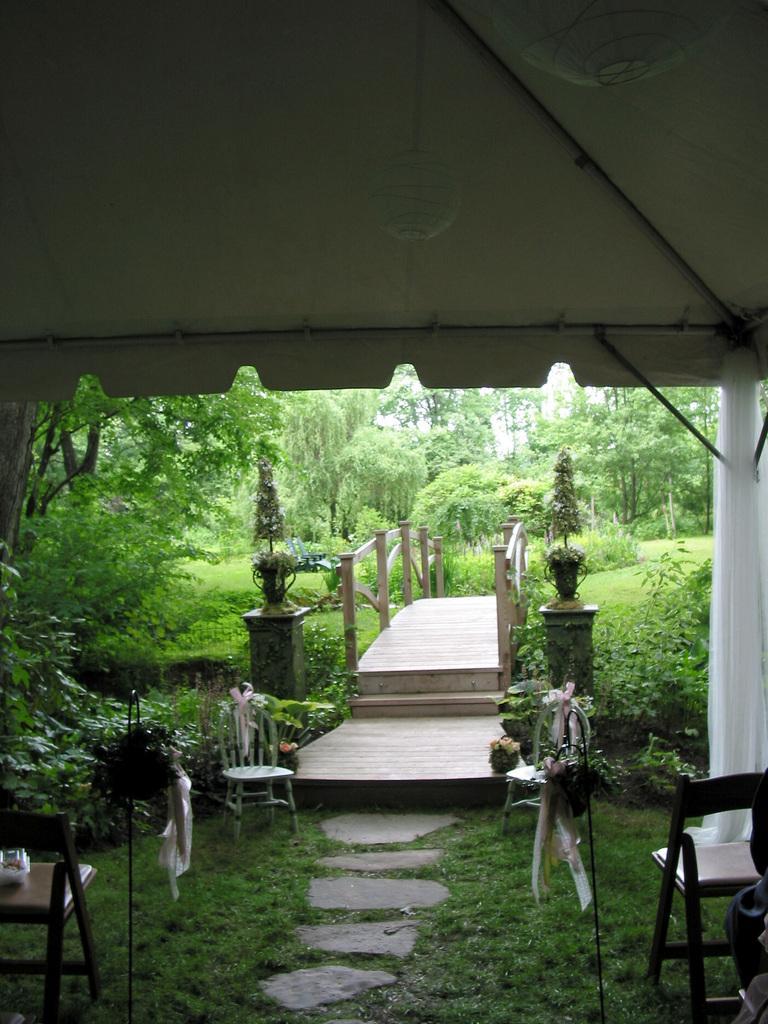How would you summarize this image in a sentence or two? In the center of the image there are stairs. There is a railing. There are flower pots. On the right side of the image there is a pillar. There are chairs. At the bottom of the image there is grass on the surface. In the background of the image there are trees. 